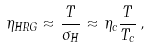Convert formula to latex. <formula><loc_0><loc_0><loc_500><loc_500>\eta _ { H R G } \approx \frac { T } { \sigma _ { H } } \approx \eta _ { c } \frac { T } { T _ { c } } \, ,</formula> 